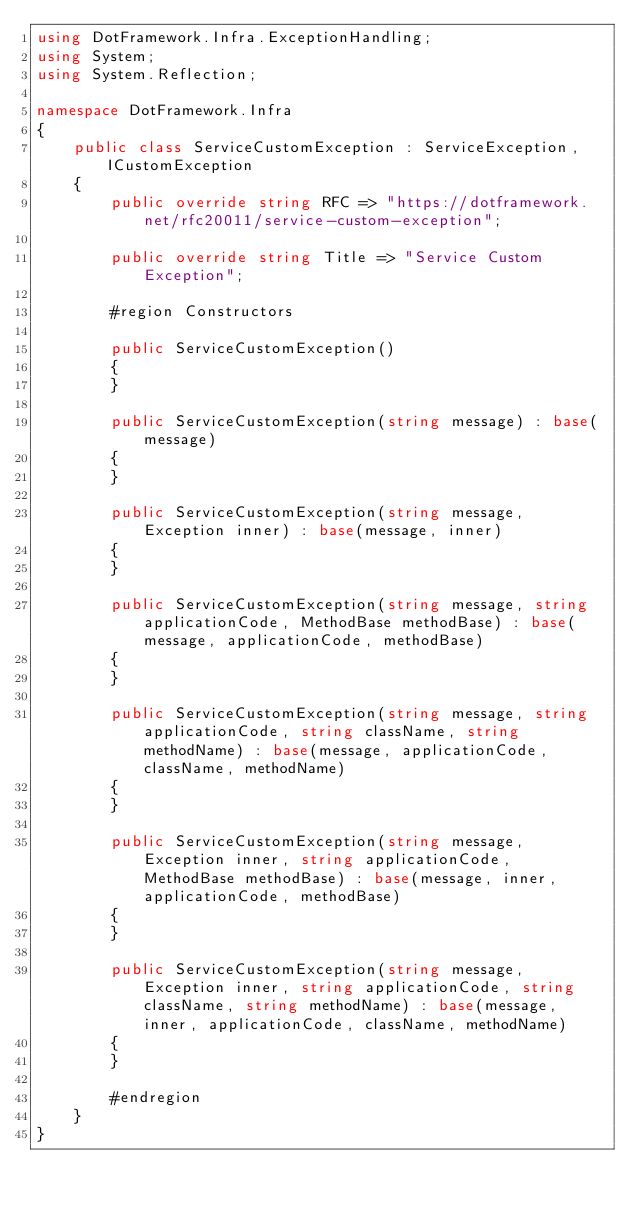Convert code to text. <code><loc_0><loc_0><loc_500><loc_500><_C#_>using DotFramework.Infra.ExceptionHandling;
using System;
using System.Reflection;

namespace DotFramework.Infra
{
    public class ServiceCustomException : ServiceException, ICustomException
    {
        public override string RFC => "https://dotframework.net/rfc20011/service-custom-exception";

        public override string Title => "Service Custom Exception";

        #region Constructors

        public ServiceCustomException()
        {
        }

        public ServiceCustomException(string message) : base(message)
        {
        }

        public ServiceCustomException(string message, Exception inner) : base(message, inner)
        {
        }

        public ServiceCustomException(string message, string applicationCode, MethodBase methodBase) : base(message, applicationCode, methodBase)
        {
        }

        public ServiceCustomException(string message, string applicationCode, string className, string methodName) : base(message, applicationCode, className, methodName)
        {
        }

        public ServiceCustomException(string message, Exception inner, string applicationCode, MethodBase methodBase) : base(message, inner, applicationCode, methodBase)
        {
        }

        public ServiceCustomException(string message, Exception inner, string applicationCode, string className, string methodName) : base(message, inner, applicationCode, className, methodName)
        {
        }

        #endregion
    }
}
</code> 